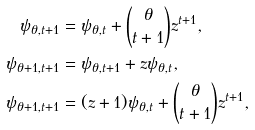Convert formula to latex. <formula><loc_0><loc_0><loc_500><loc_500>\psi _ { \theta , t + 1 } & = \psi _ { \theta , t } + { \theta \choose { t + 1 } } z ^ { t + 1 } , \\ \psi _ { \theta + 1 , t + 1 } & = \psi _ { \theta , t + 1 } + z \psi _ { \theta , t } , \\ \psi _ { \theta + 1 , t + 1 } & = ( z + 1 ) \psi _ { \theta , t } + { \theta \choose { t + 1 } } z ^ { t + 1 } ,</formula> 